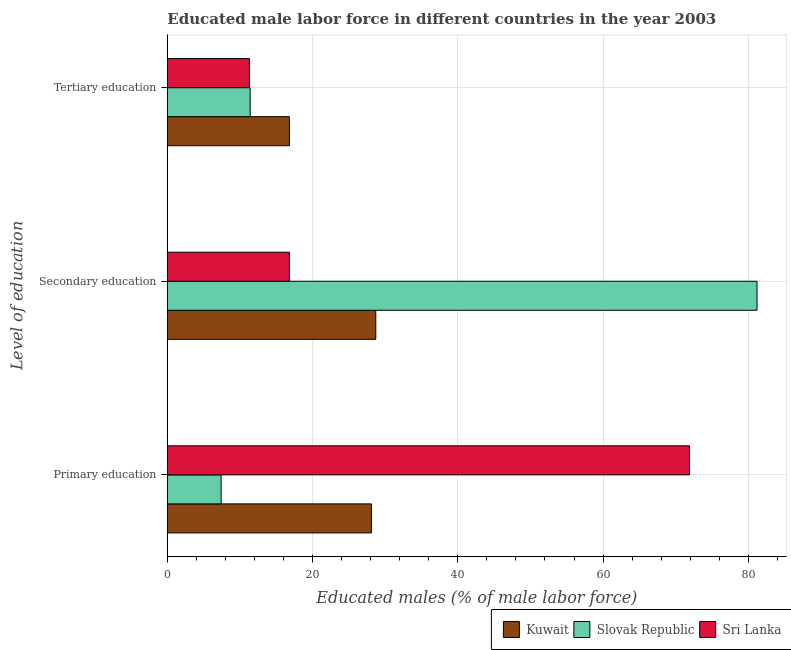How many groups of bars are there?
Your answer should be compact. 3. How many bars are there on the 1st tick from the bottom?
Provide a short and direct response. 3. What is the percentage of male labor force who received primary education in Slovak Republic?
Ensure brevity in your answer.  7.4. Across all countries, what is the maximum percentage of male labor force who received secondary education?
Your answer should be compact. 81.2. Across all countries, what is the minimum percentage of male labor force who received tertiary education?
Ensure brevity in your answer.  11.3. In which country was the percentage of male labor force who received secondary education maximum?
Offer a terse response. Slovak Republic. In which country was the percentage of male labor force who received tertiary education minimum?
Provide a succinct answer. Sri Lanka. What is the total percentage of male labor force who received secondary education in the graph?
Ensure brevity in your answer.  126.7. What is the difference between the percentage of male labor force who received tertiary education in Sri Lanka and that in Slovak Republic?
Your response must be concise. -0.1. What is the difference between the percentage of male labor force who received tertiary education in Kuwait and the percentage of male labor force who received primary education in Slovak Republic?
Your answer should be very brief. 9.4. What is the average percentage of male labor force who received primary education per country?
Your answer should be compact. 35.8. What is the difference between the percentage of male labor force who received primary education and percentage of male labor force who received secondary education in Slovak Republic?
Your answer should be very brief. -73.8. What is the ratio of the percentage of male labor force who received primary education in Kuwait to that in Slovak Republic?
Your answer should be compact. 3.8. What is the difference between the highest and the second highest percentage of male labor force who received tertiary education?
Keep it short and to the point. 5.4. What is the difference between the highest and the lowest percentage of male labor force who received secondary education?
Provide a short and direct response. 64.4. Is the sum of the percentage of male labor force who received tertiary education in Slovak Republic and Sri Lanka greater than the maximum percentage of male labor force who received primary education across all countries?
Make the answer very short. No. What does the 3rd bar from the top in Primary education represents?
Keep it short and to the point. Kuwait. What does the 2nd bar from the bottom in Primary education represents?
Make the answer very short. Slovak Republic. Is it the case that in every country, the sum of the percentage of male labor force who received primary education and percentage of male labor force who received secondary education is greater than the percentage of male labor force who received tertiary education?
Your answer should be compact. Yes. How many bars are there?
Offer a terse response. 9. Are all the bars in the graph horizontal?
Provide a short and direct response. Yes. How many countries are there in the graph?
Your answer should be compact. 3. Are the values on the major ticks of X-axis written in scientific E-notation?
Provide a short and direct response. No. What is the title of the graph?
Your answer should be compact. Educated male labor force in different countries in the year 2003. Does "French Polynesia" appear as one of the legend labels in the graph?
Your answer should be very brief. No. What is the label or title of the X-axis?
Ensure brevity in your answer.  Educated males (% of male labor force). What is the label or title of the Y-axis?
Offer a terse response. Level of education. What is the Educated males (% of male labor force) of Kuwait in Primary education?
Keep it short and to the point. 28.1. What is the Educated males (% of male labor force) of Slovak Republic in Primary education?
Make the answer very short. 7.4. What is the Educated males (% of male labor force) of Sri Lanka in Primary education?
Give a very brief answer. 71.9. What is the Educated males (% of male labor force) of Kuwait in Secondary education?
Ensure brevity in your answer.  28.7. What is the Educated males (% of male labor force) of Slovak Republic in Secondary education?
Give a very brief answer. 81.2. What is the Educated males (% of male labor force) of Sri Lanka in Secondary education?
Provide a succinct answer. 16.8. What is the Educated males (% of male labor force) in Kuwait in Tertiary education?
Offer a terse response. 16.8. What is the Educated males (% of male labor force) of Slovak Republic in Tertiary education?
Your answer should be compact. 11.4. What is the Educated males (% of male labor force) in Sri Lanka in Tertiary education?
Your answer should be very brief. 11.3. Across all Level of education, what is the maximum Educated males (% of male labor force) of Kuwait?
Your response must be concise. 28.7. Across all Level of education, what is the maximum Educated males (% of male labor force) of Slovak Republic?
Your response must be concise. 81.2. Across all Level of education, what is the maximum Educated males (% of male labor force) in Sri Lanka?
Offer a very short reply. 71.9. Across all Level of education, what is the minimum Educated males (% of male labor force) of Kuwait?
Make the answer very short. 16.8. Across all Level of education, what is the minimum Educated males (% of male labor force) of Slovak Republic?
Your answer should be very brief. 7.4. Across all Level of education, what is the minimum Educated males (% of male labor force) in Sri Lanka?
Ensure brevity in your answer.  11.3. What is the total Educated males (% of male labor force) in Kuwait in the graph?
Your answer should be very brief. 73.6. What is the difference between the Educated males (% of male labor force) of Slovak Republic in Primary education and that in Secondary education?
Provide a short and direct response. -73.8. What is the difference between the Educated males (% of male labor force) of Sri Lanka in Primary education and that in Secondary education?
Your answer should be very brief. 55.1. What is the difference between the Educated males (% of male labor force) in Sri Lanka in Primary education and that in Tertiary education?
Your response must be concise. 60.6. What is the difference between the Educated males (% of male labor force) of Slovak Republic in Secondary education and that in Tertiary education?
Offer a very short reply. 69.8. What is the difference between the Educated males (% of male labor force) of Kuwait in Primary education and the Educated males (% of male labor force) of Slovak Republic in Secondary education?
Provide a short and direct response. -53.1. What is the difference between the Educated males (% of male labor force) of Slovak Republic in Primary education and the Educated males (% of male labor force) of Sri Lanka in Secondary education?
Your response must be concise. -9.4. What is the difference between the Educated males (% of male labor force) in Kuwait in Primary education and the Educated males (% of male labor force) in Slovak Republic in Tertiary education?
Your answer should be compact. 16.7. What is the difference between the Educated males (% of male labor force) of Kuwait in Primary education and the Educated males (% of male labor force) of Sri Lanka in Tertiary education?
Provide a short and direct response. 16.8. What is the difference between the Educated males (% of male labor force) in Kuwait in Secondary education and the Educated males (% of male labor force) in Slovak Republic in Tertiary education?
Make the answer very short. 17.3. What is the difference between the Educated males (% of male labor force) in Kuwait in Secondary education and the Educated males (% of male labor force) in Sri Lanka in Tertiary education?
Your answer should be very brief. 17.4. What is the difference between the Educated males (% of male labor force) in Slovak Republic in Secondary education and the Educated males (% of male labor force) in Sri Lanka in Tertiary education?
Provide a succinct answer. 69.9. What is the average Educated males (% of male labor force) of Kuwait per Level of education?
Your answer should be compact. 24.53. What is the average Educated males (% of male labor force) of Slovak Republic per Level of education?
Make the answer very short. 33.33. What is the average Educated males (% of male labor force) in Sri Lanka per Level of education?
Give a very brief answer. 33.33. What is the difference between the Educated males (% of male labor force) in Kuwait and Educated males (% of male labor force) in Slovak Republic in Primary education?
Your response must be concise. 20.7. What is the difference between the Educated males (% of male labor force) of Kuwait and Educated males (% of male labor force) of Sri Lanka in Primary education?
Offer a terse response. -43.8. What is the difference between the Educated males (% of male labor force) in Slovak Republic and Educated males (% of male labor force) in Sri Lanka in Primary education?
Provide a succinct answer. -64.5. What is the difference between the Educated males (% of male labor force) of Kuwait and Educated males (% of male labor force) of Slovak Republic in Secondary education?
Provide a succinct answer. -52.5. What is the difference between the Educated males (% of male labor force) in Kuwait and Educated males (% of male labor force) in Sri Lanka in Secondary education?
Your answer should be very brief. 11.9. What is the difference between the Educated males (% of male labor force) in Slovak Republic and Educated males (% of male labor force) in Sri Lanka in Secondary education?
Offer a terse response. 64.4. What is the difference between the Educated males (% of male labor force) in Slovak Republic and Educated males (% of male labor force) in Sri Lanka in Tertiary education?
Your response must be concise. 0.1. What is the ratio of the Educated males (% of male labor force) in Kuwait in Primary education to that in Secondary education?
Give a very brief answer. 0.98. What is the ratio of the Educated males (% of male labor force) of Slovak Republic in Primary education to that in Secondary education?
Provide a succinct answer. 0.09. What is the ratio of the Educated males (% of male labor force) of Sri Lanka in Primary education to that in Secondary education?
Offer a very short reply. 4.28. What is the ratio of the Educated males (% of male labor force) of Kuwait in Primary education to that in Tertiary education?
Your answer should be very brief. 1.67. What is the ratio of the Educated males (% of male labor force) in Slovak Republic in Primary education to that in Tertiary education?
Your answer should be compact. 0.65. What is the ratio of the Educated males (% of male labor force) of Sri Lanka in Primary education to that in Tertiary education?
Make the answer very short. 6.36. What is the ratio of the Educated males (% of male labor force) in Kuwait in Secondary education to that in Tertiary education?
Ensure brevity in your answer.  1.71. What is the ratio of the Educated males (% of male labor force) of Slovak Republic in Secondary education to that in Tertiary education?
Ensure brevity in your answer.  7.12. What is the ratio of the Educated males (% of male labor force) in Sri Lanka in Secondary education to that in Tertiary education?
Ensure brevity in your answer.  1.49. What is the difference between the highest and the second highest Educated males (% of male labor force) of Slovak Republic?
Keep it short and to the point. 69.8. What is the difference between the highest and the second highest Educated males (% of male labor force) in Sri Lanka?
Offer a very short reply. 55.1. What is the difference between the highest and the lowest Educated males (% of male labor force) of Slovak Republic?
Provide a succinct answer. 73.8. What is the difference between the highest and the lowest Educated males (% of male labor force) of Sri Lanka?
Your response must be concise. 60.6. 